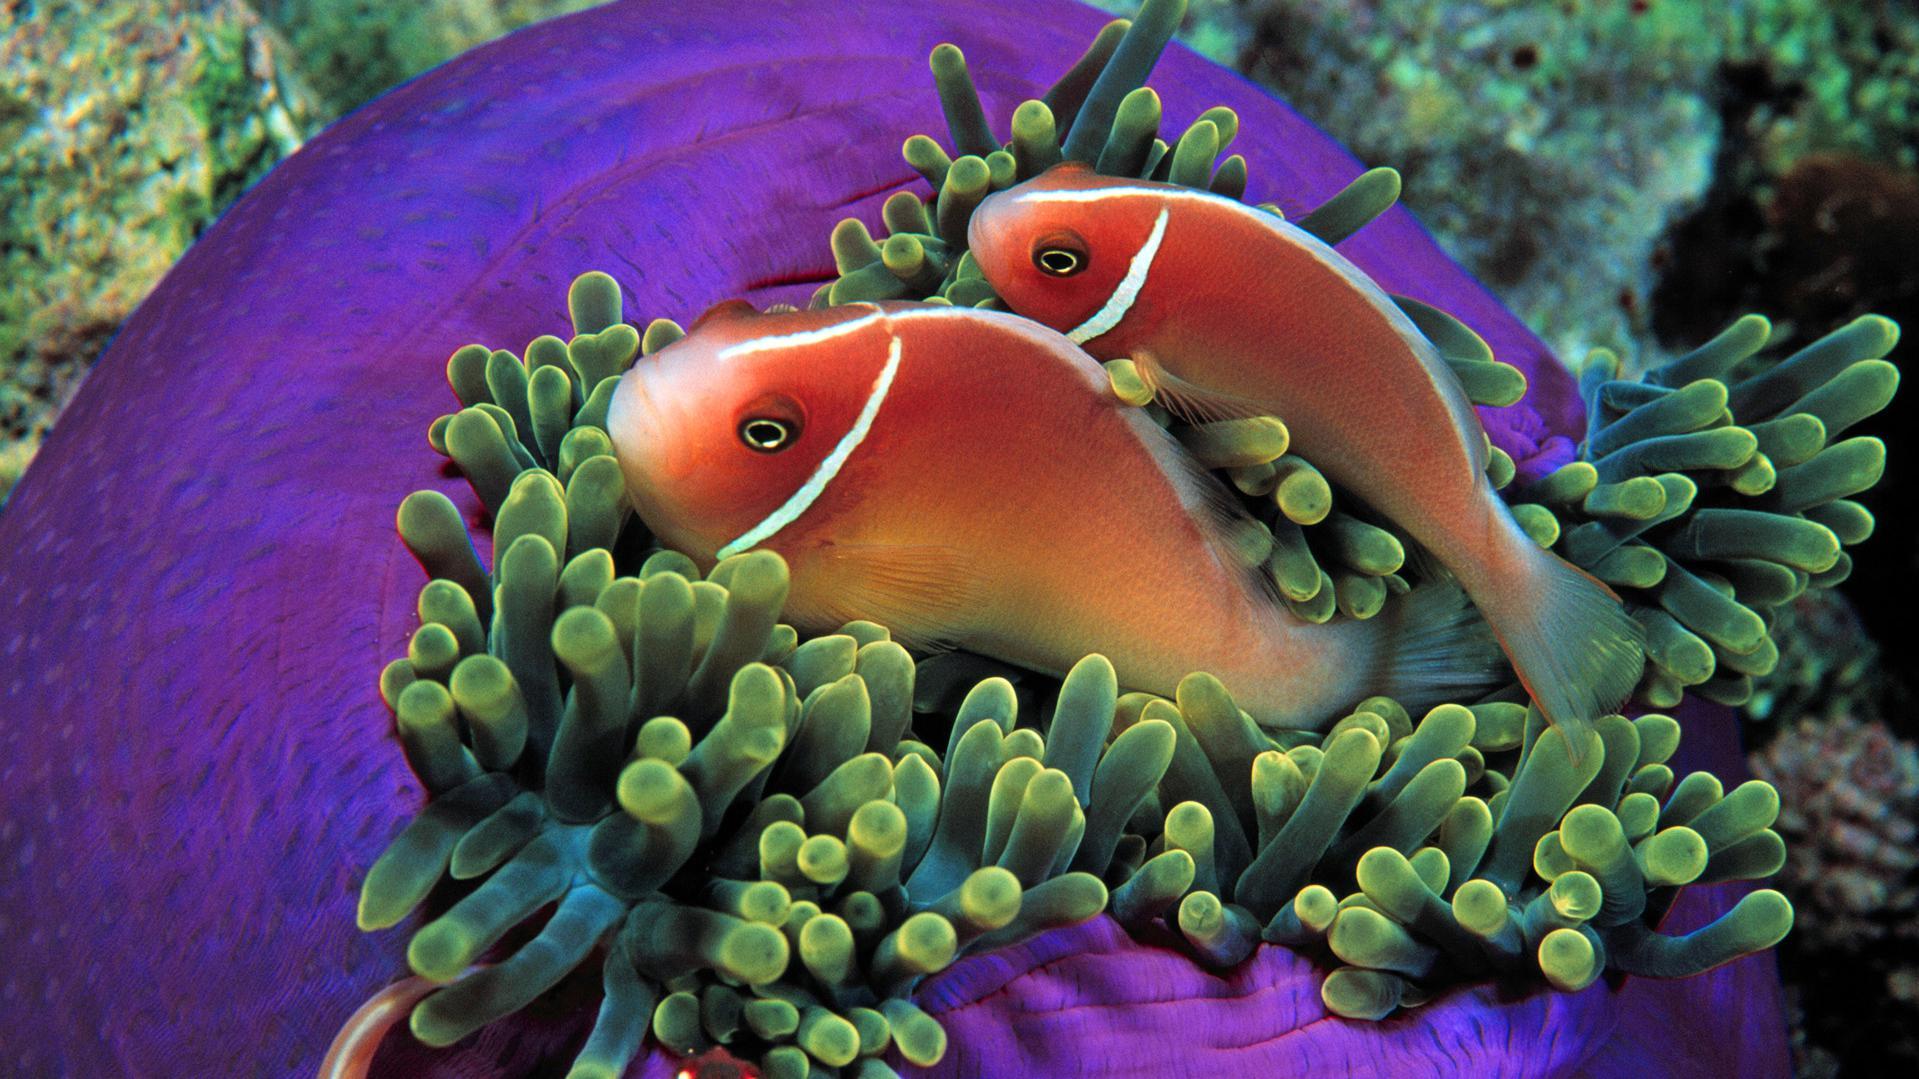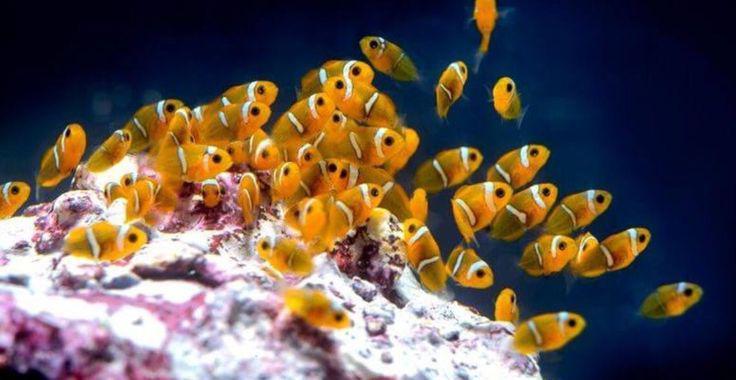The first image is the image on the left, the second image is the image on the right. Given the left and right images, does the statement "there are two orange and white colored fish swimming near an anemone" hold true? Answer yes or no. Yes. 